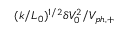Convert formula to latex. <formula><loc_0><loc_0><loc_500><loc_500>( k / L _ { 0 } ) ^ { 1 / 2 } \delta V _ { 0 } ^ { 2 } / V _ { p h , + }</formula> 